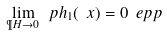Convert formula to latex. <formula><loc_0><loc_0><loc_500><loc_500>\lim _ { \P H \rightarrow 0 } \ p h _ { 1 } ( \ x ) = 0 \ e p p</formula> 